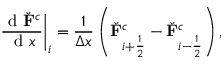<formula> <loc_0><loc_0><loc_500><loc_500>\frac { d \check { F } ^ { c } } { d x } \right | _ { i } = \frac { 1 } { \Delta x } \left ( \check { F } _ { i + \frac { 1 } { 2 } } ^ { c } - \check { F } _ { i - \frac { 1 } { 2 } } ^ { c } \right ) ,</formula> 